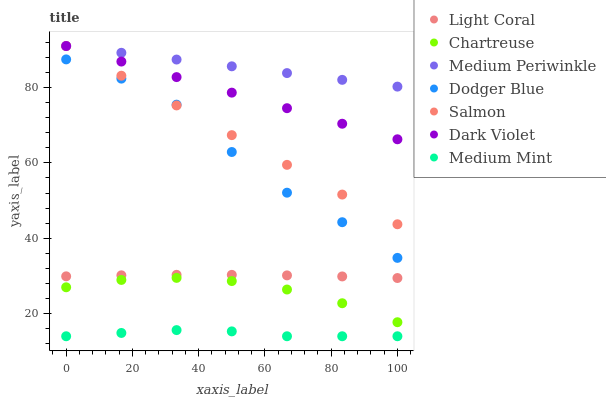Does Medium Mint have the minimum area under the curve?
Answer yes or no. Yes. Does Medium Periwinkle have the maximum area under the curve?
Answer yes or no. Yes. Does Salmon have the minimum area under the curve?
Answer yes or no. No. Does Salmon have the maximum area under the curve?
Answer yes or no. No. Is Medium Periwinkle the smoothest?
Answer yes or no. Yes. Is Dodger Blue the roughest?
Answer yes or no. Yes. Is Salmon the smoothest?
Answer yes or no. No. Is Salmon the roughest?
Answer yes or no. No. Does Medium Mint have the lowest value?
Answer yes or no. Yes. Does Salmon have the lowest value?
Answer yes or no. No. Does Dark Violet have the highest value?
Answer yes or no. Yes. Does Light Coral have the highest value?
Answer yes or no. No. Is Light Coral less than Dodger Blue?
Answer yes or no. Yes. Is Medium Periwinkle greater than Medium Mint?
Answer yes or no. Yes. Does Dark Violet intersect Salmon?
Answer yes or no. Yes. Is Dark Violet less than Salmon?
Answer yes or no. No. Is Dark Violet greater than Salmon?
Answer yes or no. No. Does Light Coral intersect Dodger Blue?
Answer yes or no. No. 